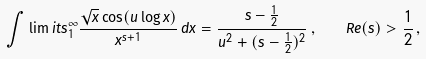Convert formula to latex. <formula><loc_0><loc_0><loc_500><loc_500>\int \lim i t s _ { 1 } ^ { \infty } \frac { \sqrt { x } \cos ( u \log x ) } { x ^ { s + 1 } } \, d x = \frac { s - \frac { 1 } { 2 } } { u ^ { 2 } + ( s - \frac { 1 } { 2 } ) ^ { 2 } } \, , \quad R e ( s ) > \frac { 1 } { 2 } \, ,</formula> 